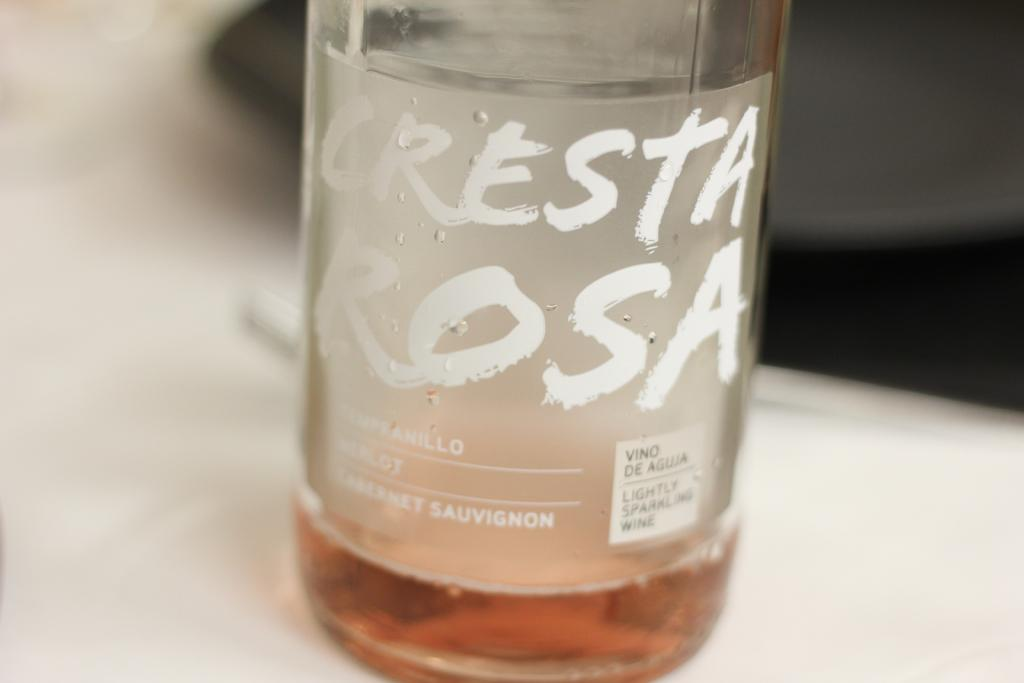<image>
Give a short and clear explanation of the subsequent image. An almost empty bottle of Crest rosa is sitting on a table. 